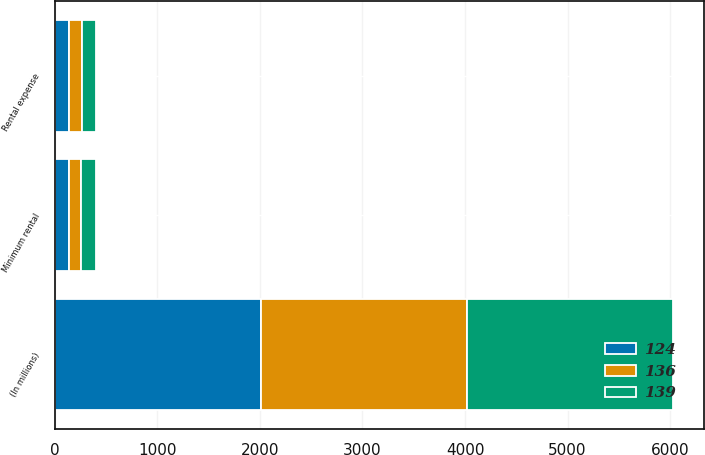<chart> <loc_0><loc_0><loc_500><loc_500><stacked_bar_chart><ecel><fcel>(In millions)<fcel>Minimum rental<fcel>Rental expense<nl><fcel>139<fcel>2012<fcel>139<fcel>139<nl><fcel>136<fcel>2011<fcel>123<fcel>124<nl><fcel>124<fcel>2010<fcel>135<fcel>136<nl></chart> 